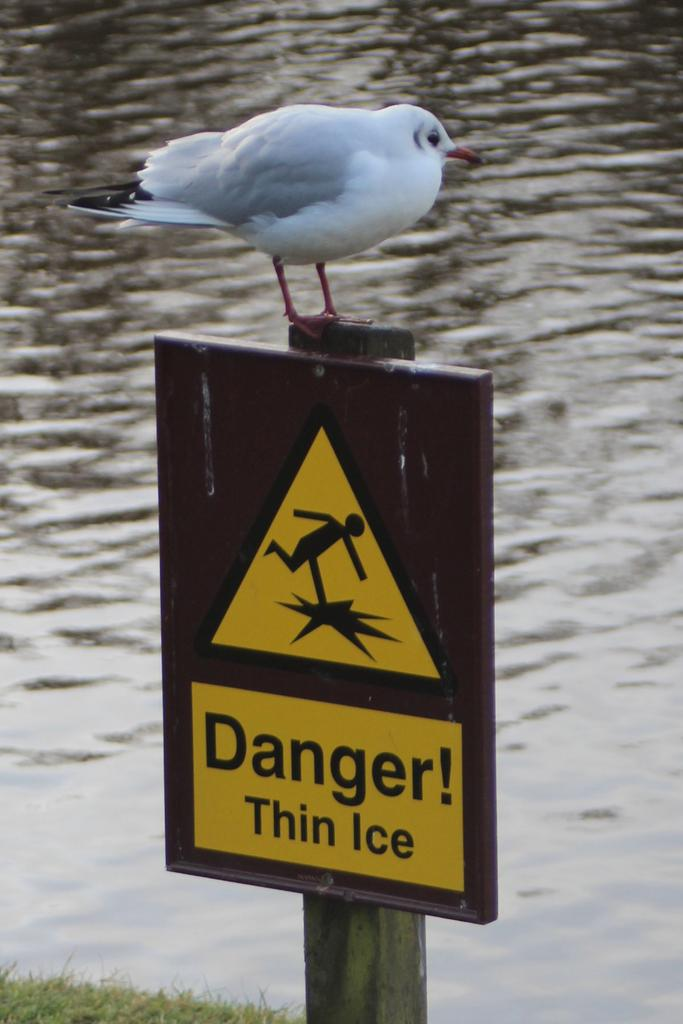What is the main subject of the image? There is a bird on a caution board in the image. Can you describe the appearance of the bird? The bird is white and black in color. What can be seen on the ground in the image? There is water and grass visible on the ground in the image. How many snails can be seen crawling on the grass in the image? There are no snails visible in the image; it only features a bird on a caution board, water, and grass. What type of rabbit is hiding in the grass in the image? There is no rabbit present in the image; it only features a bird on a caution board, water, and grass. 